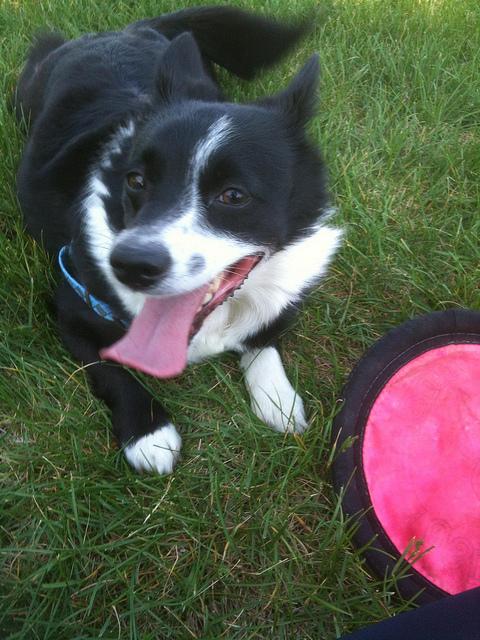Did the dog catch the frisbee?
Be succinct. No. Does the dog look thirsty?
Keep it brief. Yes. Is the dog happy?
Short answer required. Yes. What color is the dog's collar?
Answer briefly. Blue. 